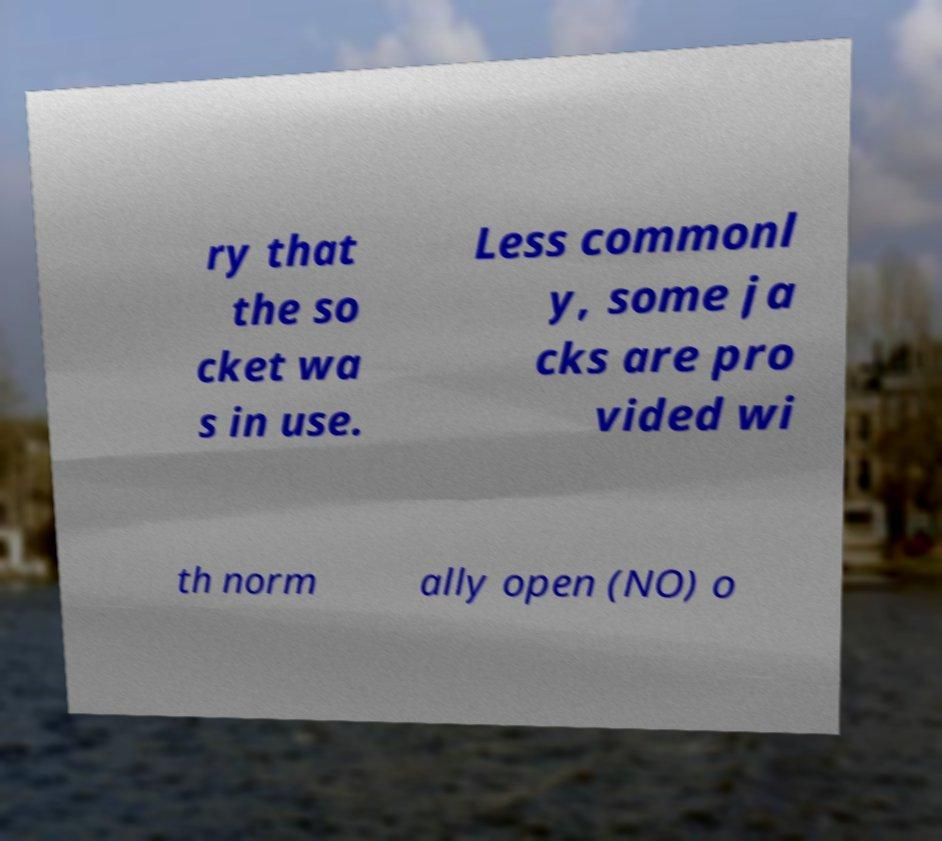For documentation purposes, I need the text within this image transcribed. Could you provide that? ry that the so cket wa s in use. Less commonl y, some ja cks are pro vided wi th norm ally open (NO) o 